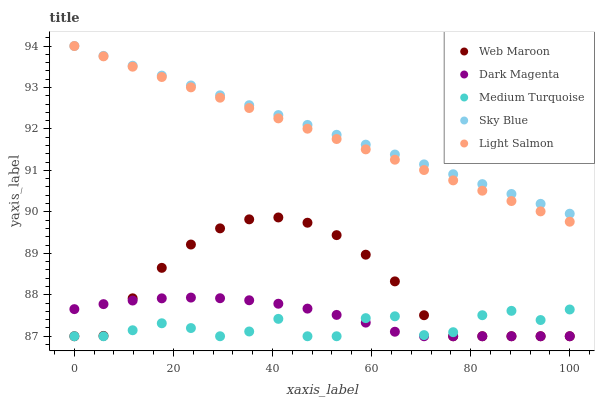Does Medium Turquoise have the minimum area under the curve?
Answer yes or no. Yes. Does Sky Blue have the maximum area under the curve?
Answer yes or no. Yes. Does Light Salmon have the minimum area under the curve?
Answer yes or no. No. Does Light Salmon have the maximum area under the curve?
Answer yes or no. No. Is Sky Blue the smoothest?
Answer yes or no. Yes. Is Medium Turquoise the roughest?
Answer yes or no. Yes. Is Light Salmon the smoothest?
Answer yes or no. No. Is Light Salmon the roughest?
Answer yes or no. No. Does Web Maroon have the lowest value?
Answer yes or no. Yes. Does Light Salmon have the lowest value?
Answer yes or no. No. Does Light Salmon have the highest value?
Answer yes or no. Yes. Does Web Maroon have the highest value?
Answer yes or no. No. Is Medium Turquoise less than Light Salmon?
Answer yes or no. Yes. Is Sky Blue greater than Web Maroon?
Answer yes or no. Yes. Does Medium Turquoise intersect Dark Magenta?
Answer yes or no. Yes. Is Medium Turquoise less than Dark Magenta?
Answer yes or no. No. Is Medium Turquoise greater than Dark Magenta?
Answer yes or no. No. Does Medium Turquoise intersect Light Salmon?
Answer yes or no. No. 